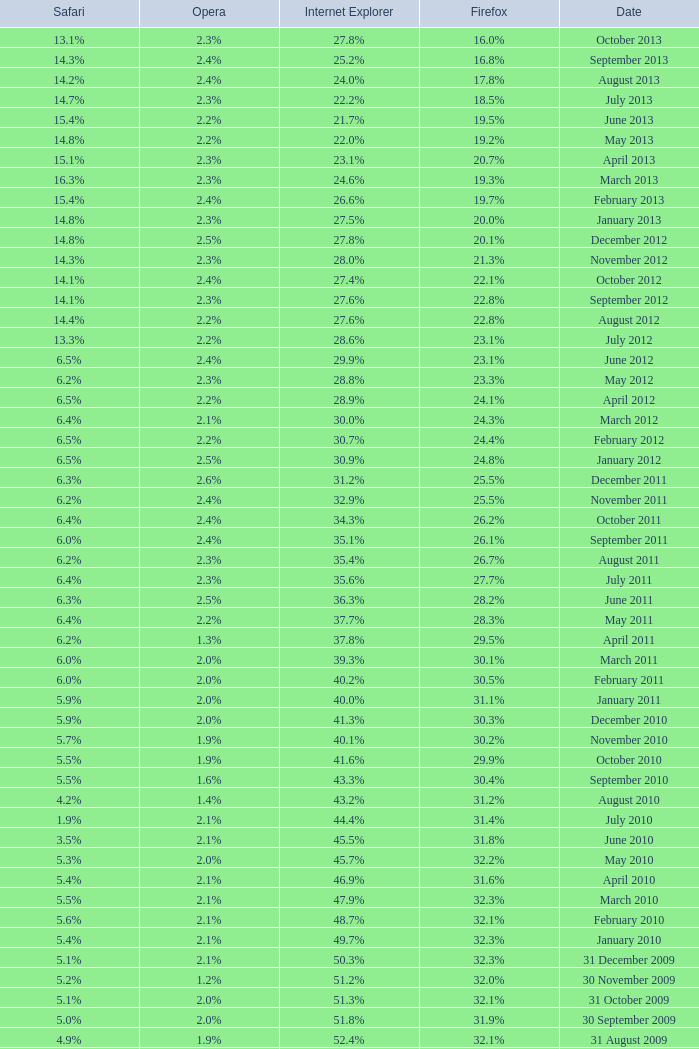I'm looking to parse the entire table for insights. Could you assist me with that? {'header': ['Safari', 'Opera', 'Internet Explorer', 'Firefox', 'Date'], 'rows': [['13.1%', '2.3%', '27.8%', '16.0%', 'October 2013'], ['14.3%', '2.4%', '25.2%', '16.8%', 'September 2013'], ['14.2%', '2.4%', '24.0%', '17.8%', 'August 2013'], ['14.7%', '2.3%', '22.2%', '18.5%', 'July 2013'], ['15.4%', '2.2%', '21.7%', '19.5%', 'June 2013'], ['14.8%', '2.2%', '22.0%', '19.2%', 'May 2013'], ['15.1%', '2.3%', '23.1%', '20.7%', 'April 2013'], ['16.3%', '2.3%', '24.6%', '19.3%', 'March 2013'], ['15.4%', '2.4%', '26.6%', '19.7%', 'February 2013'], ['14.8%', '2.3%', '27.5%', '20.0%', 'January 2013'], ['14.8%', '2.5%', '27.8%', '20.1%', 'December 2012'], ['14.3%', '2.3%', '28.0%', '21.3%', 'November 2012'], ['14.1%', '2.4%', '27.4%', '22.1%', 'October 2012'], ['14.1%', '2.3%', '27.6%', '22.8%', 'September 2012'], ['14.4%', '2.2%', '27.6%', '22.8%', 'August 2012'], ['13.3%', '2.2%', '28.6%', '23.1%', 'July 2012'], ['6.5%', '2.4%', '29.9%', '23.1%', 'June 2012'], ['6.2%', '2.3%', '28.8%', '23.3%', 'May 2012'], ['6.5%', '2.2%', '28.9%', '24.1%', 'April 2012'], ['6.4%', '2.1%', '30.0%', '24.3%', 'March 2012'], ['6.5%', '2.2%', '30.7%', '24.4%', 'February 2012'], ['6.5%', '2.5%', '30.9%', '24.8%', 'January 2012'], ['6.3%', '2.6%', '31.2%', '25.5%', 'December 2011'], ['6.2%', '2.4%', '32.9%', '25.5%', 'November 2011'], ['6.4%', '2.4%', '34.3%', '26.2%', 'October 2011'], ['6.0%', '2.4%', '35.1%', '26.1%', 'September 2011'], ['6.2%', '2.3%', '35.4%', '26.7%', 'August 2011'], ['6.4%', '2.3%', '35.6%', '27.7%', 'July 2011'], ['6.3%', '2.5%', '36.3%', '28.2%', 'June 2011'], ['6.4%', '2.2%', '37.7%', '28.3%', 'May 2011'], ['6.2%', '1.3%', '37.8%', '29.5%', 'April 2011'], ['6.0%', '2.0%', '39.3%', '30.1%', 'March 2011'], ['6.0%', '2.0%', '40.2%', '30.5%', 'February 2011'], ['5.9%', '2.0%', '40.0%', '31.1%', 'January 2011'], ['5.9%', '2.0%', '41.3%', '30.3%', 'December 2010'], ['5.7%', '1.9%', '40.1%', '30.2%', 'November 2010'], ['5.5%', '1.9%', '41.6%', '29.9%', 'October 2010'], ['5.5%', '1.6%', '43.3%', '30.4%', 'September 2010'], ['4.2%', '1.4%', '43.2%', '31.2%', 'August 2010'], ['1.9%', '2.1%', '44.4%', '31.4%', 'July 2010'], ['3.5%', '2.1%', '45.5%', '31.8%', 'June 2010'], ['5.3%', '2.0%', '45.7%', '32.2%', 'May 2010'], ['5.4%', '2.1%', '46.9%', '31.6%', 'April 2010'], ['5.5%', '2.1%', '47.9%', '32.3%', 'March 2010'], ['5.6%', '2.1%', '48.7%', '32.1%', 'February 2010'], ['5.4%', '2.1%', '49.7%', '32.3%', 'January 2010'], ['5.1%', '2.1%', '50.3%', '32.3%', '31 December 2009'], ['5.2%', '1.2%', '51.2%', '32.0%', '30 November 2009'], ['5.1%', '2.0%', '51.3%', '32.1%', '31 October 2009'], ['5.0%', '2.0%', '51.8%', '31.9%', '30 September 2009'], ['4.9%', '1.9%', '52.4%', '32.1%', '31 August 2009'], ['4.6%', '1.8%', '53.1%', '31.7%', '31 July 2009'], ['3.2%', '2.0%', '57.1%', '31.6%', '30 June 2009'], ['3.1%', '2.0%', '57.5%', '31.4%', '31 May 2009'], ['2.9%', '2.0%', '57.6%', '31.6%', '30 April 2009'], ['2.8%', '2.0%', '57.8%', '31.5%', '31 March 2009'], ['2.7%', '2.0%', '58.1%', '31.3%', '28 February 2009'], ['2.7%', '2.0%', '58.4%', '31.1%', '31 January 2009'], ['2.9%', '2.1%', '58.6%', '31.1%', '31 December 2008'], ['3.0%', '2.0%', '59.0%', '30.8%', '30 November 2008'], ['3.0%', '2.0%', '59.4%', '30.6%', '31 October 2008'], ['2.7%', '2.0%', '57.3%', '32.5%', '30 September 2008'], ['2.4%', '2.1%', '58.7%', '31.4%', '31 August 2008'], ['2.4%', '2.0%', '60.9%', '29.7%', '31 July 2008'], ['2.5%', '2.0%', '61.7%', '29.1%', '30 June 2008'], ['2.7%', '2.0%', '61.9%', '28.9%', '31 May 2008'], ['2.8%', '2.0%', '62.0%', '28.8%', '30 April 2008'], ['2.8%', '2.0%', '62.0%', '28.8%', '31 March 2008'], ['2.8%', '2.0%', '62.0%', '28.7%', '29 February 2008'], ['2.7%', '2.0%', '62.2%', '28.7%', '31 January 2008'], ['2.6%', '2.0%', '62.8%', '28.0%', '1 December 2007'], ['2.5%', '2.0%', '63.0%', '27.8%', '10 November 2007'], ['2.3%', '1.8%', '65.5%', '26.3%', '30 October 2007'], ['2.1%', '1.8%', '66.6%', '25.6%', '20 September 2007'], ['2.1%', '1.8%', '66.7%', '25.5%', '30 August 2007'], ['2.2%', '1.8%', '66.9%', '25.1%', '30 July 2007'], ['2.3%', '1.8%', '66.9%', '25.1%', '30 June 2007'], ['2.4%', '1.8%', '67.1%', '24.8%', '30 May 2007'], ['Safari', 'Opera', 'Internet Explorer', 'Firefox', 'Date']]} What is the safari value with a 2.4% opera and 29.9% internet explorer? 6.5%. 